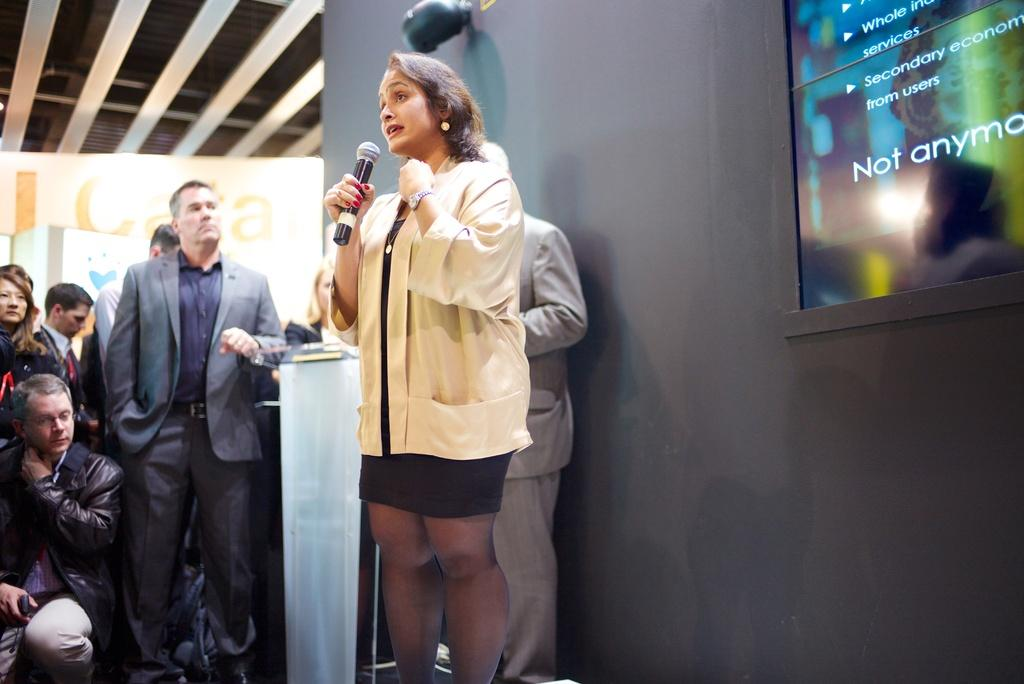What can be seen in the background of the image? There is a wall in the image. Who is present in the image? There are people in the image. Can you describe the woman in the front of the image? The woman in the front of the image is wearing a white jacket and holding a mic. Are there any cherries visible on the wall in the image? There are no cherries present on the wall in the image. Is the woman in the front of the image a spy? There is no information in the image to suggest that the woman is a spy. 